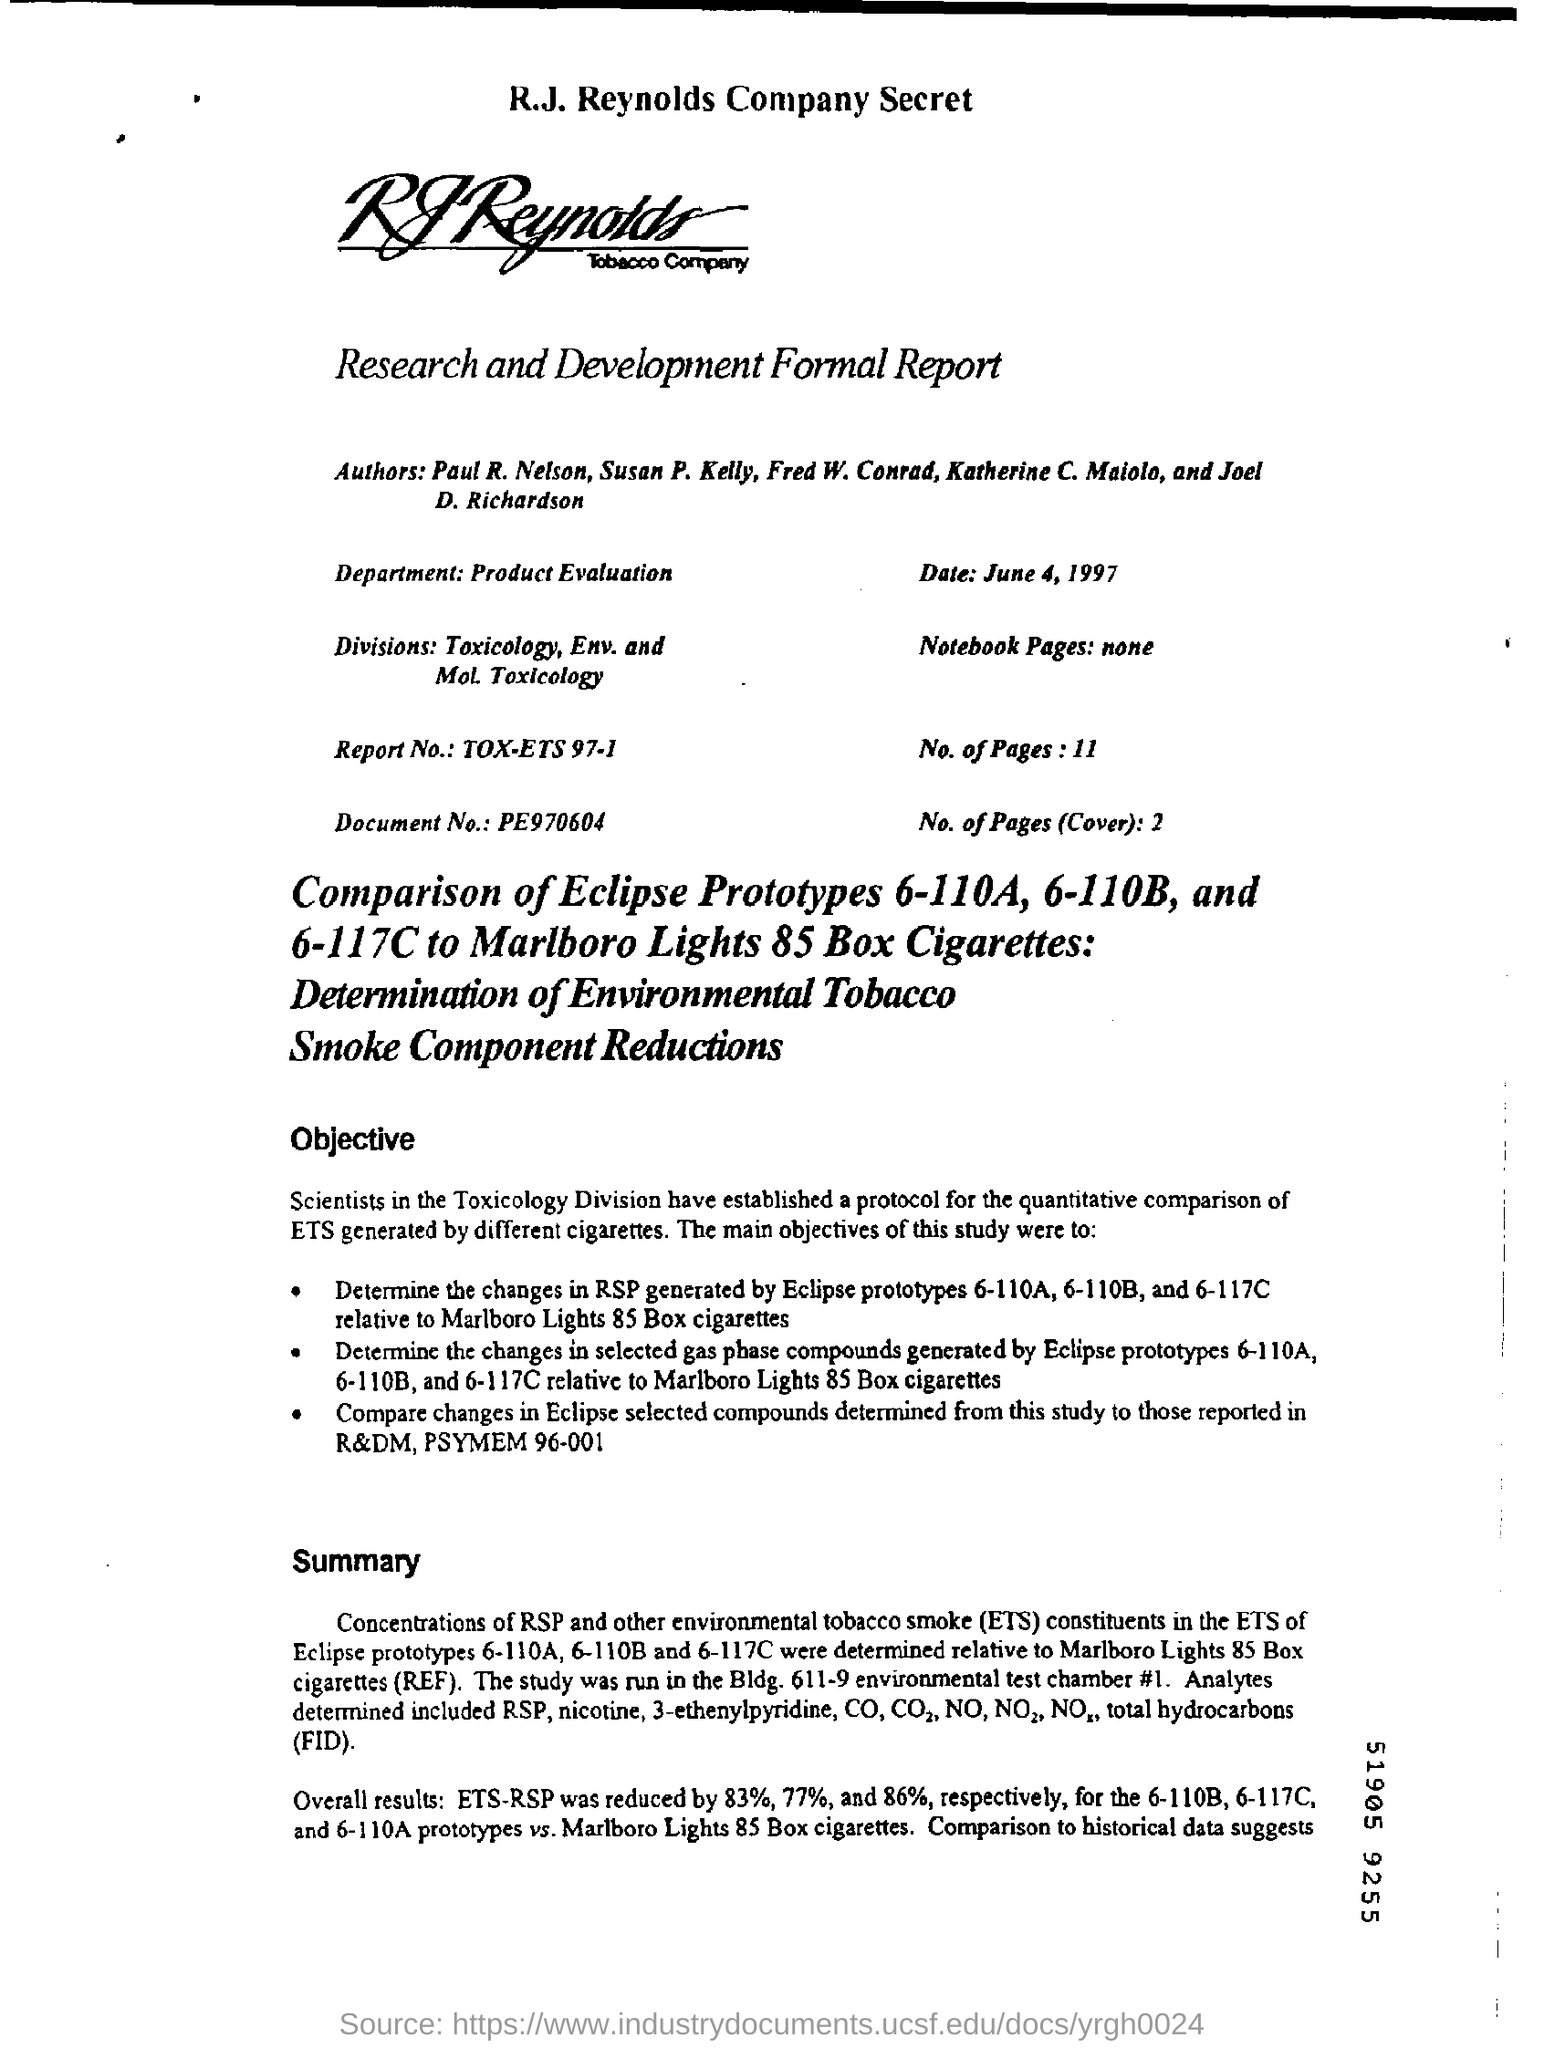Outline some significant characteristics in this image. The document number is PE970604. The Report No is tox-ets 97-1. The date reported in the report is June 4, 1997. The division in the Research and Development Formal Report is named Toxicology, Environmental, and Molecular Toxicology. The department in the Research and Development Formal Report that evaluates products is called Product Evaluation. 